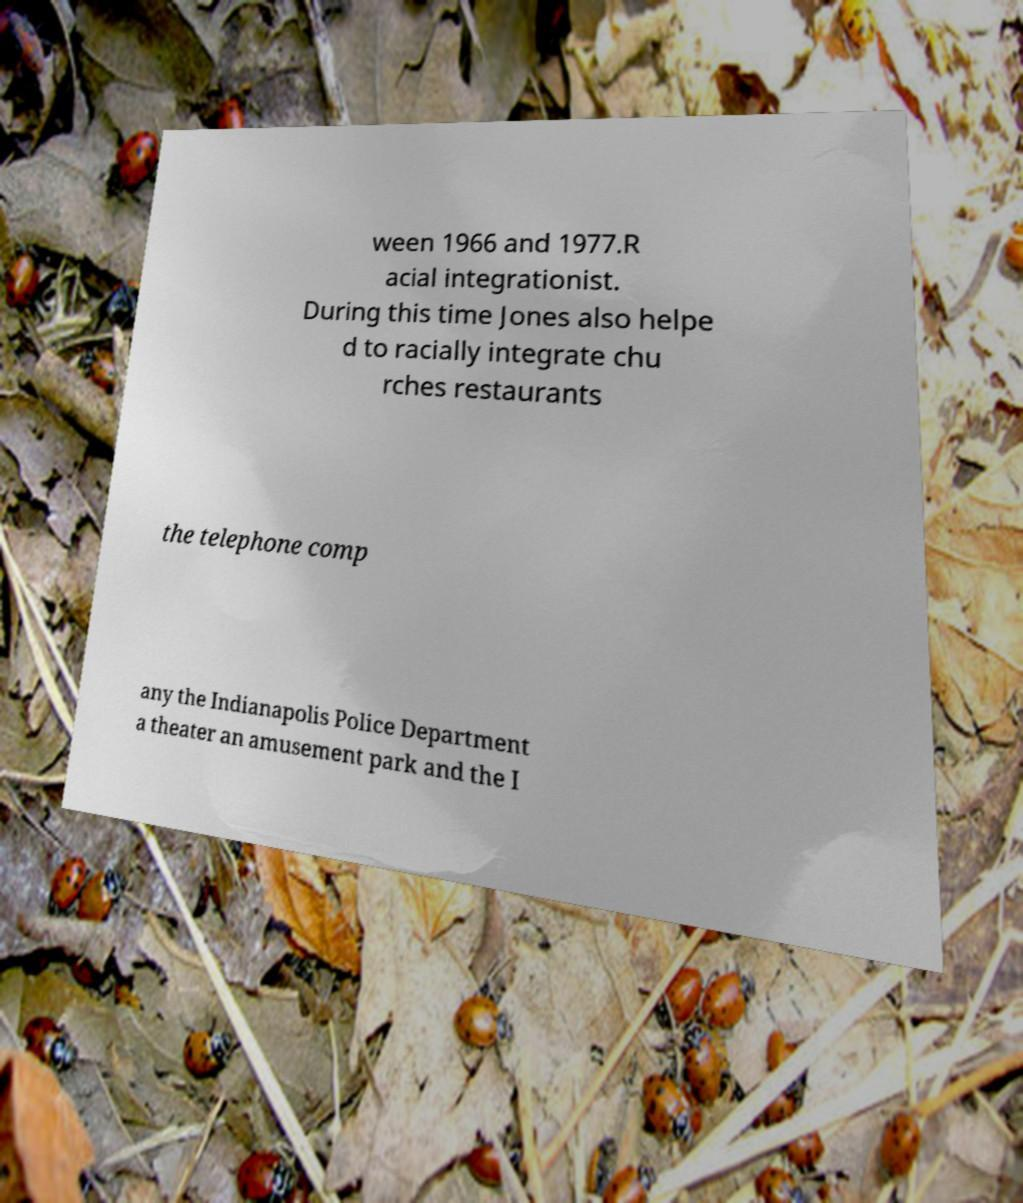There's text embedded in this image that I need extracted. Can you transcribe it verbatim? ween 1966 and 1977.R acial integrationist. During this time Jones also helpe d to racially integrate chu rches restaurants the telephone comp any the Indianapolis Police Department a theater an amusement park and the I 